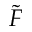<formula> <loc_0><loc_0><loc_500><loc_500>\tilde { F }</formula> 